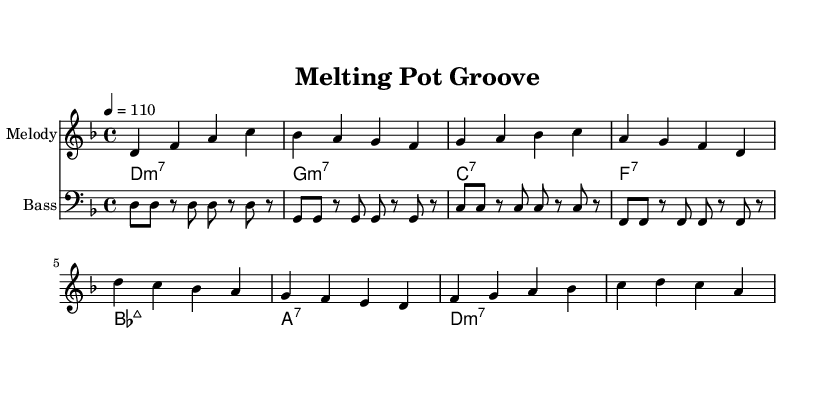What is the key signature of this music? The key signature is D minor, which has one flat (B flat) and indicates that the piece centers around the D minor scale.
Answer: D minor What is the time signature of this piece? The time signature is 4/4, meaning there are four beats in each measure and a quarter note receives one beat.
Answer: 4/4 What is the tempo marking for this composition? The tempo marking is 110 beats per minute, indicating a moderately fast pace for the piece.
Answer: 110 What chord is used in the first measure? The first measure contains a D minor 7 chord, as indicated in the chord names section next to the melody line.
Answer: D minor 7 How many measures are present in the main theme? The main theme consists of four measures, which can be counted from the provided notation in the score.
Answer: 4 What style of music does this composition represent? This composition represents Funk music, which is evident in its rhythmic and upbeat style focusing on groove and danceability.
Answer: Funk In which time signature are the bass notes primarily written? The bass notes are primarily written in the same time signature of 4/4, matching the overall structure of the piece.
Answer: 4/4 